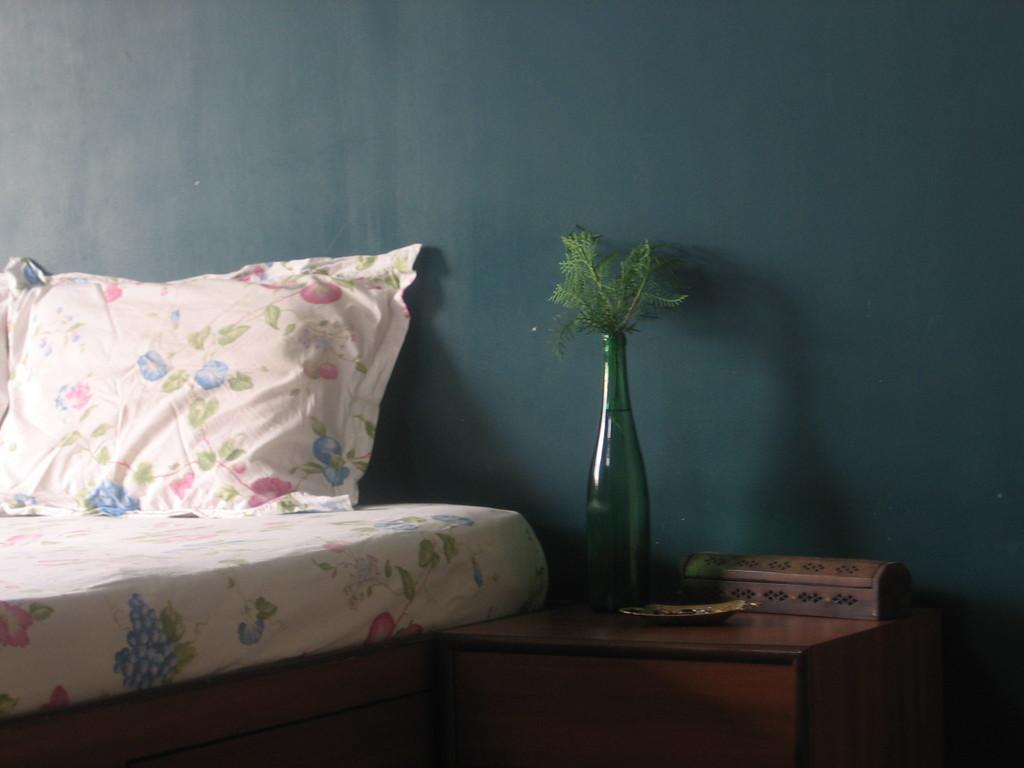What piece of furniture is in the image? There is a bed in the image. What is on the bed? There is a pillow on the bed. What is beside the bed? There is a table beside the bed. What object is on the table? There is a glass bottle on the table. What can be seen behind the bed? The background of the image is a wall. What type of mailbox is attached to the wall in the image? There is no mailbox present in the image; it only features a bed, pillow, table, glass bottle, and a wall as the background. 